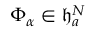Convert formula to latex. <formula><loc_0><loc_0><loc_500><loc_500>\Phi _ { \alpha } \in \mathfrak { h } _ { a } ^ { N }</formula> 